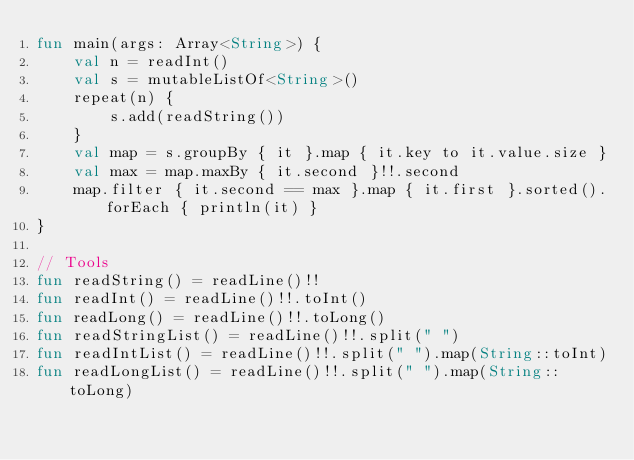<code> <loc_0><loc_0><loc_500><loc_500><_Kotlin_>fun main(args: Array<String>) {
    val n = readInt()
    val s = mutableListOf<String>()
    repeat(n) {
        s.add(readString())
    }
    val map = s.groupBy { it }.map { it.key to it.value.size }
    val max = map.maxBy { it.second }!!.second
    map.filter { it.second == max }.map { it.first }.sorted().forEach { println(it) }
}

// Tools
fun readString() = readLine()!!
fun readInt() = readLine()!!.toInt()
fun readLong() = readLine()!!.toLong()
fun readStringList() = readLine()!!.split(" ")
fun readIntList() = readLine()!!.split(" ").map(String::toInt)
fun readLongList() = readLine()!!.split(" ").map(String::toLong)</code> 